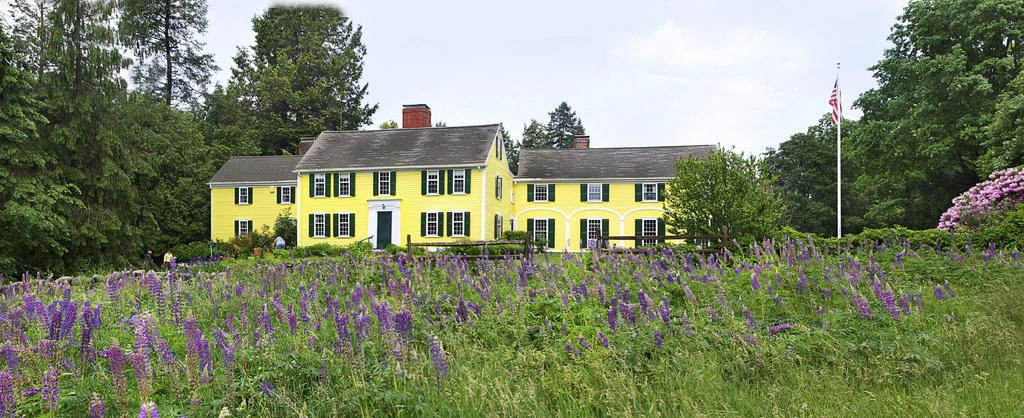What type of plants can be seen in the image? There are plants with flowers in the image. What is attached to the pole in the image? There is a flag attached to the pole in the image. What type of barrier is present in the image? There is a fence in the image. What type of vegetation is visible in the image? There are trees in the image. What type of structures are visible in the image? There are houses with windows in the image. What type of entryways are present on the houses in the image? There are doors on the houses in the image. Who or what is present in the image? There are people in the image. What can be seen in the background of the image? The sky is visible in the background of the image. How many pizzas are being served at the picnic in the image? There is no picnic or pizza present in the image. What type of chickens can be seen roaming around in the image? There are no chickens present in the image. 